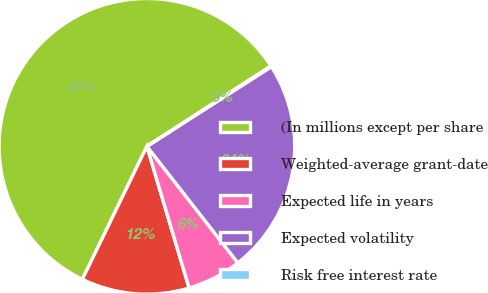<chart> <loc_0><loc_0><loc_500><loc_500><pie_chart><fcel>(In millions except per share<fcel>Weighted-average grant-date<fcel>Expected life in years<fcel>Expected volatility<fcel>Risk free interest rate<nl><fcel>58.65%<fcel>11.8%<fcel>5.94%<fcel>23.51%<fcel>0.09%<nl></chart> 